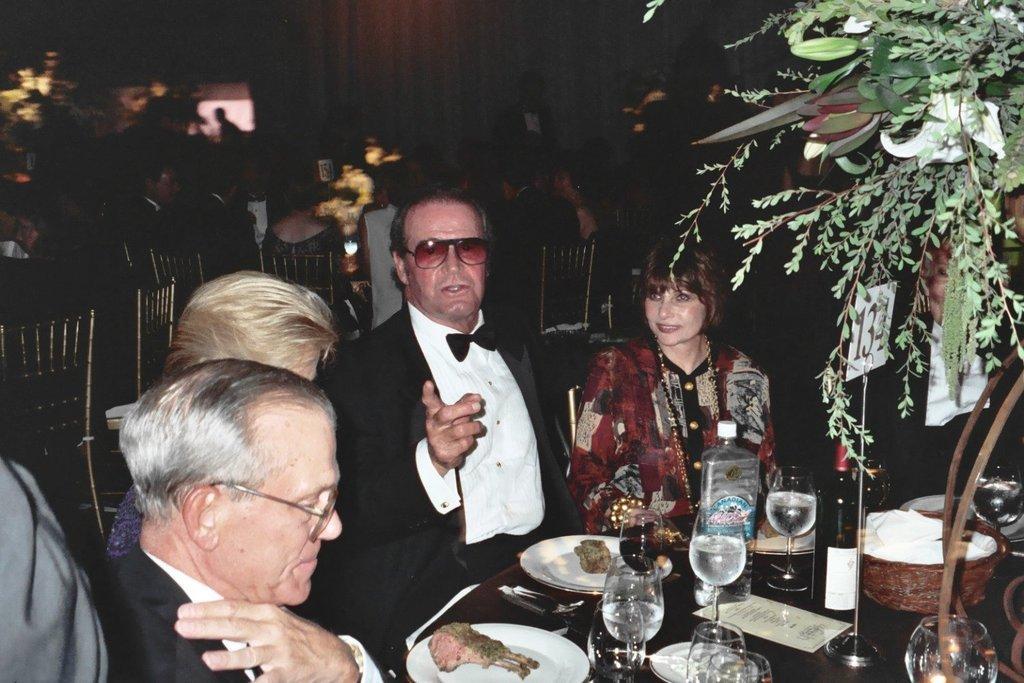Describe this image in one or two sentences. This picture is of inside. In the foreground there are a group of persons sitting on the chairs. There is a table on the top of which food items and glasses are placed. In the background we can see a wall, chairs, tables and many number of people sitting on the chairs. 